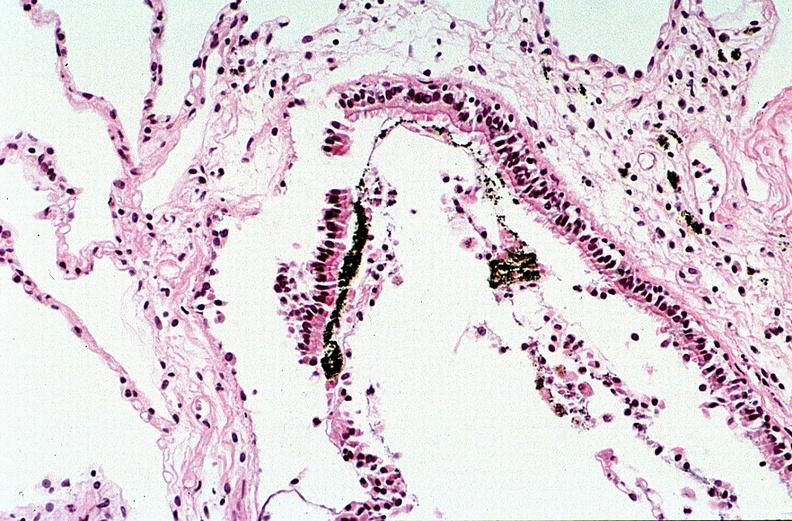what is present?
Answer the question using a single word or phrase. Respiratory 